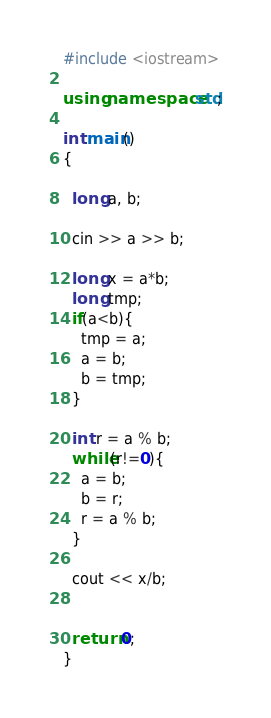Convert code to text. <code><loc_0><loc_0><loc_500><loc_500><_C++_>#include <iostream>

using namespace std;

int main()
{

  long a, b;
  
  cin >> a >> b;
  
  long x = a*b;
  long tmp;
  if(a<b){
    tmp = a;
    a = b;
    b = tmp;
  }
  
  int r = a % b;
  while(r!=0){
    a = b;
    b = r;
    r = a % b;
  }

  cout << x/b;

  
  return 0;
}
</code> 